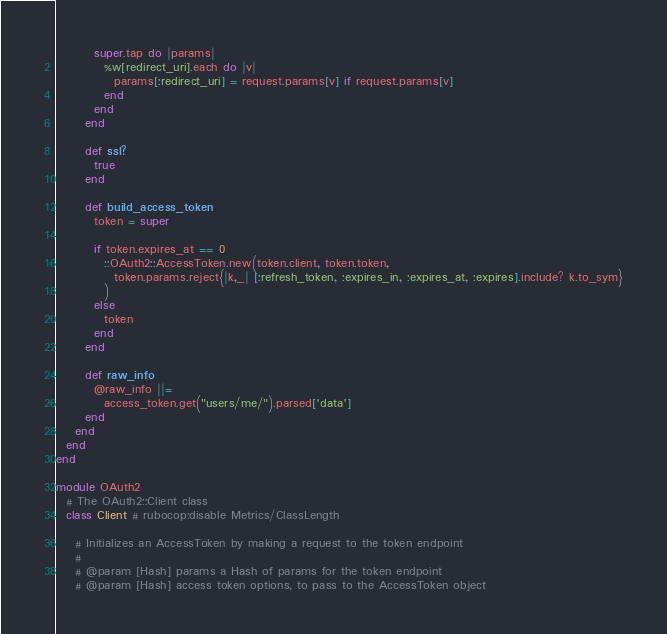Convert code to text. <code><loc_0><loc_0><loc_500><loc_500><_Ruby_>        super.tap do |params|
          %w[redirect_uri].each do |v|
            params[:redirect_uri] = request.params[v] if request.params[v]
          end
        end
      end

      def ssl?
        true
      end

      def build_access_token
        token = super

        if token.expires_at == 0
          ::OAuth2::AccessToken.new(token.client, token.token,
            token.params.reject{|k,_| [:refresh_token, :expires_in, :expires_at, :expires].include? k.to_sym}
          )
        else
          token
        end
      end

      def raw_info
        @raw_info ||=
          access_token.get("users/me/").parsed['data']
      end
    end
  end
end

module OAuth2
  # The OAuth2::Client class
  class Client # rubocop:disable Metrics/ClassLength

    # Initializes an AccessToken by making a request to the token endpoint
    #
    # @param [Hash] params a Hash of params for the token endpoint
    # @param [Hash] access token options, to pass to the AccessToken object</code> 